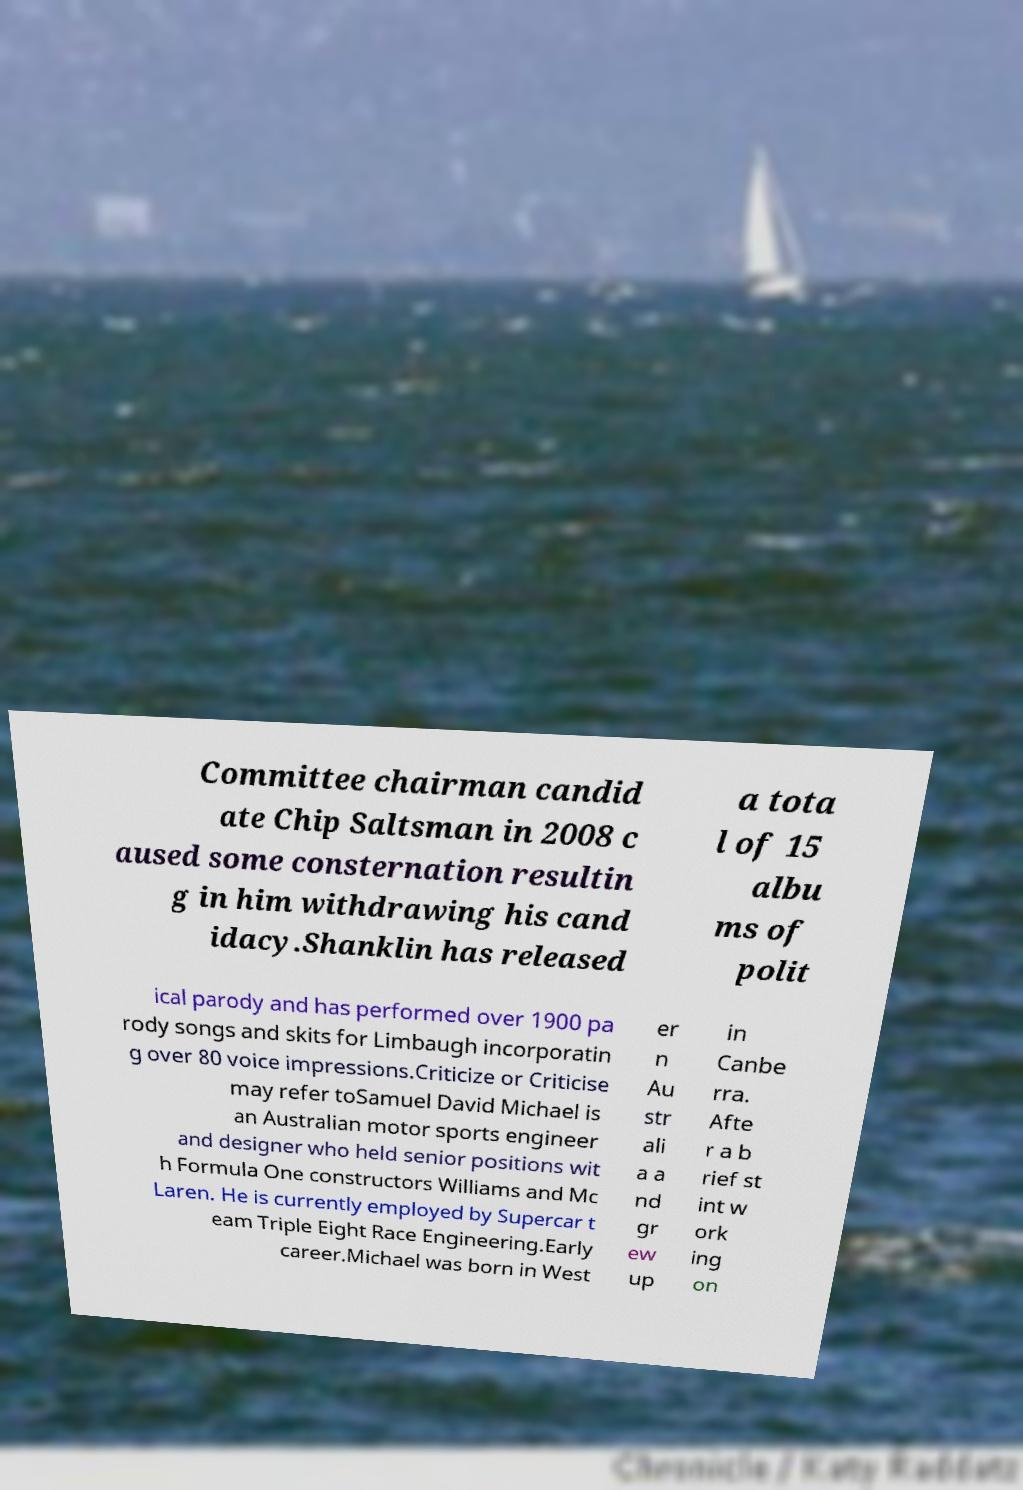Could you extract and type out the text from this image? Committee chairman candid ate Chip Saltsman in 2008 c aused some consternation resultin g in him withdrawing his cand idacy.Shanklin has released a tota l of 15 albu ms of polit ical parody and has performed over 1900 pa rody songs and skits for Limbaugh incorporatin g over 80 voice impressions.Criticize or Criticise may refer toSamuel David Michael is an Australian motor sports engineer and designer who held senior positions wit h Formula One constructors Williams and Mc Laren. He is currently employed by Supercar t eam Triple Eight Race Engineering.Early career.Michael was born in West er n Au str ali a a nd gr ew up in Canbe rra. Afte r a b rief st int w ork ing on 